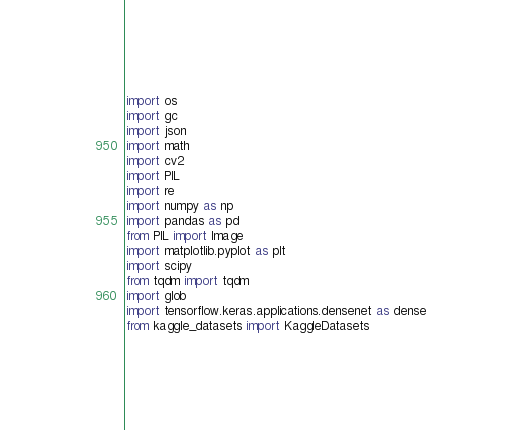Convert code to text. <code><loc_0><loc_0><loc_500><loc_500><_Python_>import os
import gc
import json
import math
import cv2
import PIL
import re
import numpy as np
import pandas as pd
from PIL import Image
import matplotlib.pyplot as plt
import scipy
from tqdm import tqdm
import glob
import tensorflow.keras.applications.densenet as dense
from kaggle_datasets import KaggleDatasets</code> 